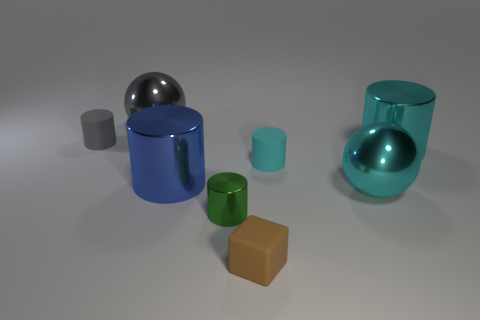Subtract all green balls. How many cyan cylinders are left? 2 Subtract all big cylinders. How many cylinders are left? 3 Subtract all green cylinders. How many cylinders are left? 4 Subtract 2 cylinders. How many cylinders are left? 3 Subtract all gray cylinders. Subtract all red spheres. How many cylinders are left? 4 Add 1 cyan rubber cylinders. How many objects exist? 9 Subtract all balls. How many objects are left? 6 Subtract all tiny purple matte things. Subtract all small cylinders. How many objects are left? 5 Add 2 metal objects. How many metal objects are left? 7 Add 3 tiny cylinders. How many tiny cylinders exist? 6 